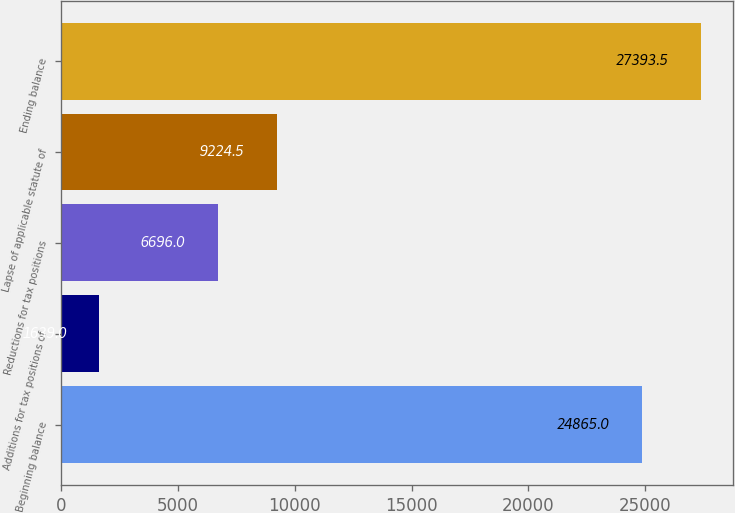Convert chart to OTSL. <chart><loc_0><loc_0><loc_500><loc_500><bar_chart><fcel>Beginning balance<fcel>Additions for tax positions of<fcel>Reductions for tax positions<fcel>Lapse of applicable statute of<fcel>Ending balance<nl><fcel>24865<fcel>1639<fcel>6696<fcel>9224.5<fcel>27393.5<nl></chart> 